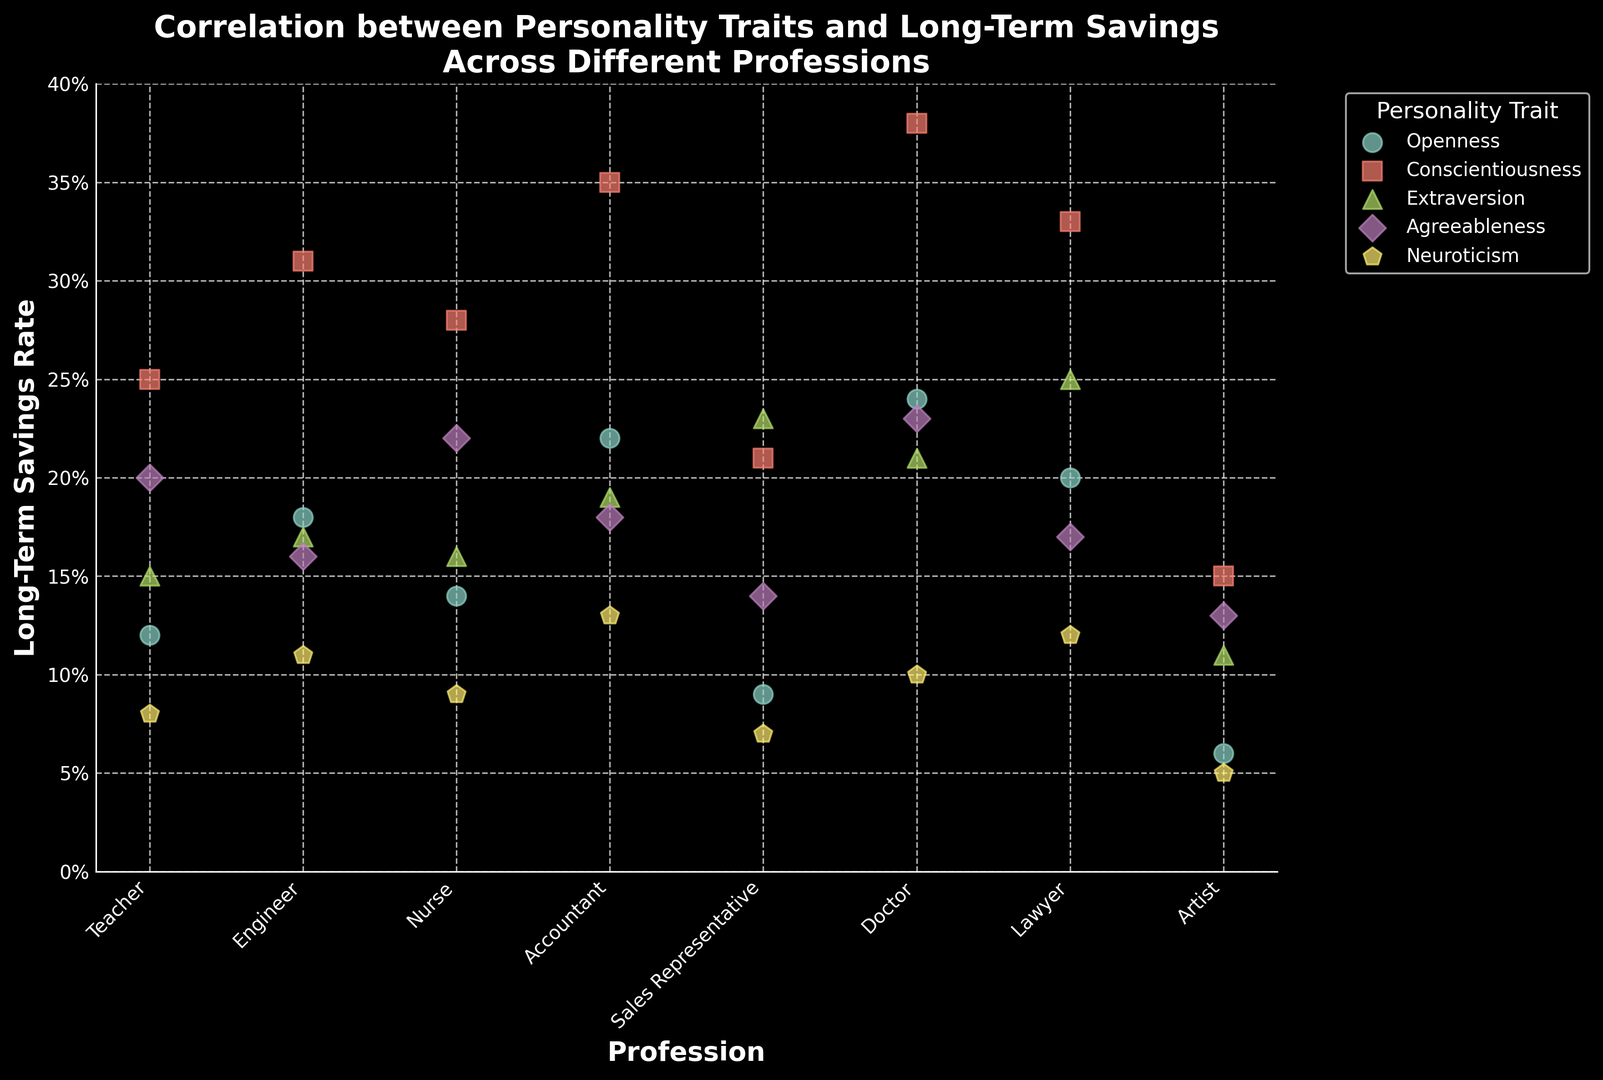Which profession has the highest long-term savings rate among those with high conscientiousness? Conscientiousness is represented by a certain color/marker. Look for the highest data point labeled with a conscientiousness marker across professions.
Answer: Doctor Which personality trait is associated with the highest long-term savings rate for accountants? Look for the data points corresponding to accountants and identify the color/marker indicating the highest long-term savings rate.
Answer: Conscientiousness Does the profession of nurses have a higher long-term savings rate with high agreeableness or high extraversion? Compare the data points for nurses with the markers/colors indicating agreeableness and extraversion.
Answer: Agreeableness Which profession shows the most variability in long-term savings rates across different personality traits? Note the spread and range of data points for each profession. Identify which profession has data points spread apart the most.
Answer: Each profession's savings vary, but doctors have points ranging from 0.10 to 0.38 What is the difference in long-term savings rate between engineers with high openness and engineers with high neuroticism? Identify the data points for engineers with openness and neuroticism markers, then calculate the difference in their long-term savings rates.
Answer: 0.07 Which profession has the lowest long-term savings rate for the trait agreeableness? Look for the data points associated with agreeableness markers and identify the lowest one for that trait.
Answer: Artist Among teachers, which personality trait shows the highest long-term savings rate and what is the rate? Identify the data points for teachers and find the color/marker corresponding to the highest rate. Provide the trait and the rate.
Answer: Conscientiousness; 0.25 Compare the long-term savings rate for sales representatives with high extraversion and sales representatives with high conscientiousness. Which is higher? Look for the markers/colors for extraversion and conscientiousness among sales representatives and compare their savings rates.
Answer: Conscientiousness Which profession and personality trait combination is associated with the lowest recorded long-term savings rate in the plot? Scan the entire plot for the data point with the lowest value and identify the corresponding profession and personality trait.
Answer: Artist; Neuroticism 